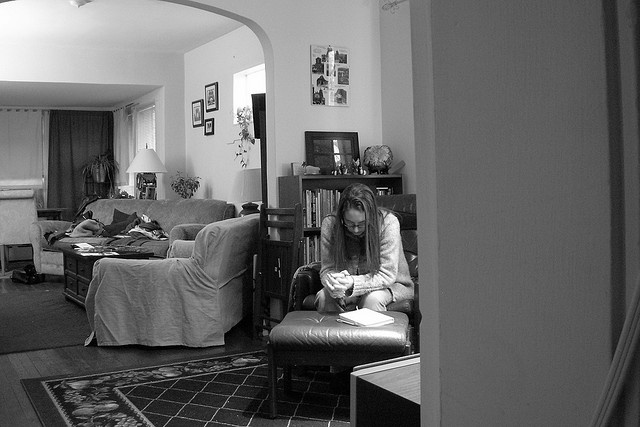Describe the objects in this image and their specific colors. I can see chair in gray, black, and lightgray tones, couch in gray, black, and lightgray tones, people in gray, black, darkgray, and lightgray tones, couch in gray, black, and lightgray tones, and chair in black, gray, and darkgray tones in this image. 